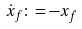Convert formula to latex. <formula><loc_0><loc_0><loc_500><loc_500>\dot { x } _ { f } \colon = - x _ { \dot { f } }</formula> 